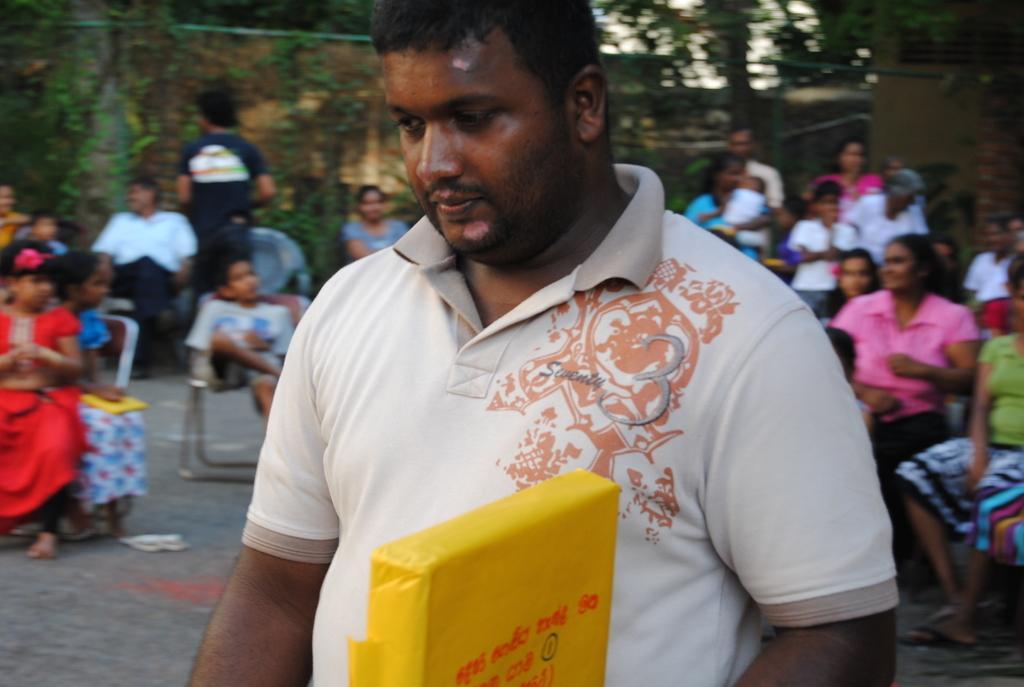Describe this image in one or two sentences. In this image in the foreground there is one person, and in the background there are group of people who are sitting and and also there are some trees and houses. At the bottom there is walkway. 